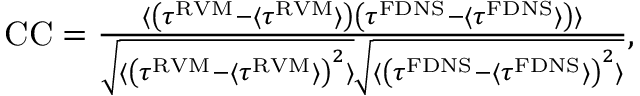<formula> <loc_0><loc_0><loc_500><loc_500>\begin{array} { r } { C C = \frac { \langle \left ( \tau ^ { R V M } - \langle \tau ^ { R V M } \rangle \right ) \left ( \tau ^ { F D N S } - \langle \tau ^ { F D N S } \rangle \right ) \rangle } { \sqrt { \langle \left ( \tau ^ { R V M } - \langle \tau ^ { R V M } \rangle \right ) ^ { 2 } \rangle } \sqrt { \langle \left ( \tau ^ { F D N S } - \langle \tau ^ { F D N S } \rangle \right ) ^ { 2 } \rangle } } , } \end{array}</formula> 